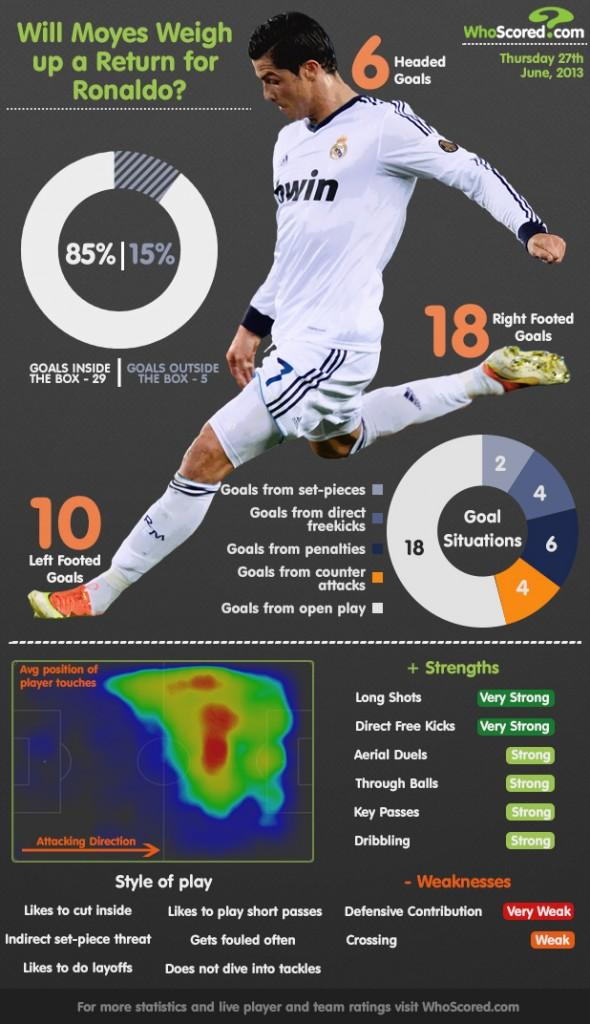Highlight a few significant elements in this photo. As of June 2013, Cristiano Ronaldo had taken a total of 4 goals from counter attacks. As of June 2013, Ronaldo had taken a total of six penalty goals. As of June 2013, Ronaldo had played a total of 5 goals that were played outside the box. As of June 2013, Ronaldo had made 18 goals from open play. Cristiano Ronaldo is known for his exceptional strength in taking long shots. 